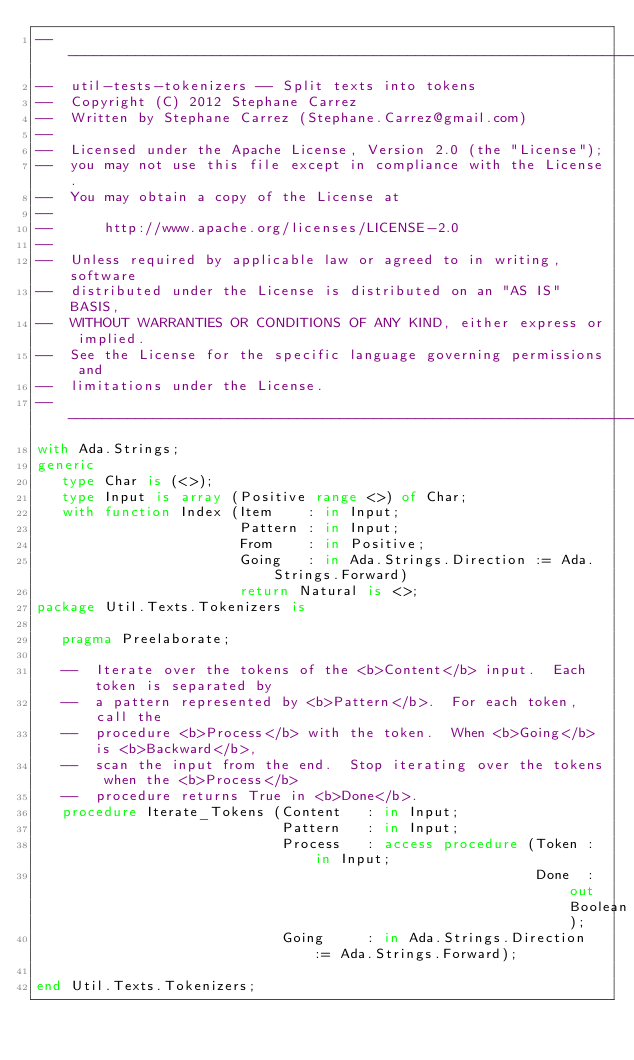Convert code to text. <code><loc_0><loc_0><loc_500><loc_500><_Ada_>-----------------------------------------------------------------------
--  util-tests-tokenizers -- Split texts into tokens
--  Copyright (C) 2012 Stephane Carrez
--  Written by Stephane Carrez (Stephane.Carrez@gmail.com)
--
--  Licensed under the Apache License, Version 2.0 (the "License");
--  you may not use this file except in compliance with the License.
--  You may obtain a copy of the License at
--
--      http://www.apache.org/licenses/LICENSE-2.0
--
--  Unless required by applicable law or agreed to in writing, software
--  distributed under the License is distributed on an "AS IS" BASIS,
--  WITHOUT WARRANTIES OR CONDITIONS OF ANY KIND, either express or implied.
--  See the License for the specific language governing permissions and
--  limitations under the License.
-----------------------------------------------------------------------
with Ada.Strings;
generic
   type Char is (<>);
   type Input is array (Positive range <>) of Char;
   with function Index (Item    : in Input;
                        Pattern : in Input;
                        From    : in Positive;
                        Going   : in Ada.Strings.Direction := Ada.Strings.Forward)
                        return Natural is <>;
package Util.Texts.Tokenizers is

   pragma Preelaborate;

   --  Iterate over the tokens of the <b>Content</b> input.  Each token is separated by
   --  a pattern represented by <b>Pattern</b>.  For each token, call the
   --  procedure <b>Process</b> with the token.  When <b>Going</b> is <b>Backward</b>,
   --  scan the input from the end.  Stop iterating over the tokens when the <b>Process</b>
   --  procedure returns True in <b>Done</b>.
   procedure Iterate_Tokens (Content   : in Input;
                             Pattern   : in Input;
                             Process   : access procedure (Token : in Input;
                                                           Done  : out Boolean);
                             Going     : in Ada.Strings.Direction := Ada.Strings.Forward);

end Util.Texts.Tokenizers;
</code> 